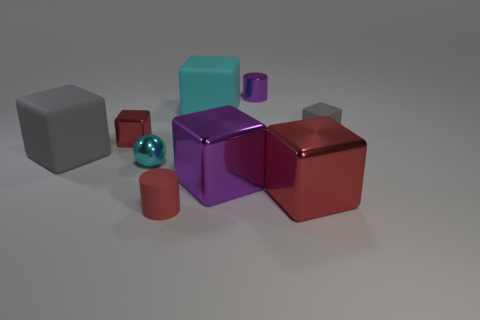What textures can be observed on the objects in the image? The objects in the image display a variety of textures. The cyan block and the red cylinder have a matte rubber texture, the gray blocks appear to have a rough, diffuse surface indicative of a stone-like texture, and the glossy, reflective sphere and cubes suggest a metallic or plastic finish. 